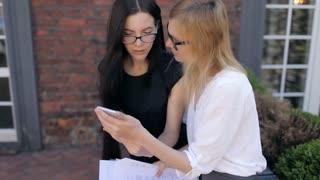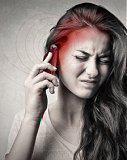The first image is the image on the left, the second image is the image on the right. Analyze the images presented: Is the assertion "There is exactly one person in every photo, and the person on the left is interacting with two phones at once, while the person on the right is showing an emotion and interacting with only one phone." valid? Answer yes or no. No. The first image is the image on the left, the second image is the image on the right. Evaluate the accuracy of this statement regarding the images: "One image shows a smiling woman holding a phone to her ear, and the other image features a man in a dark suit with something next to his ear and something held in front of him.". Is it true? Answer yes or no. No. 